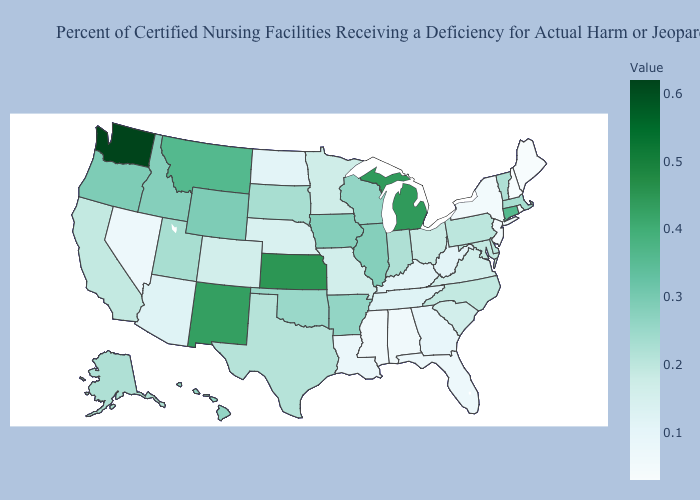Does Connecticut have a higher value than Missouri?
Short answer required. Yes. Does the map have missing data?
Write a very short answer. No. Is the legend a continuous bar?
Be succinct. Yes. Among the states that border Tennessee , which have the lowest value?
Short answer required. Alabama, Mississippi. 